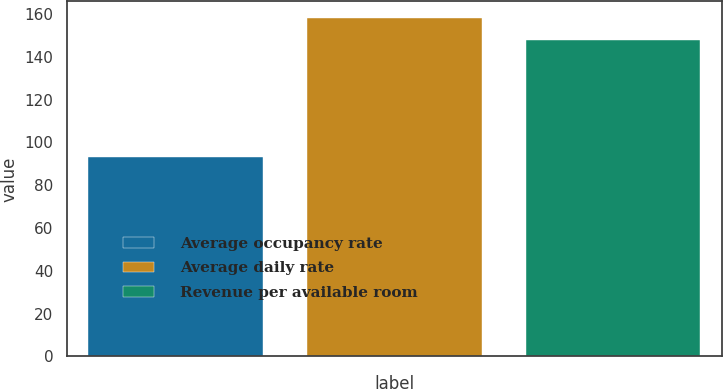Convert chart to OTSL. <chart><loc_0><loc_0><loc_500><loc_500><bar_chart><fcel>Average occupancy rate<fcel>Average daily rate<fcel>Revenue per available room<nl><fcel>93.4<fcel>158.01<fcel>147.63<nl></chart> 